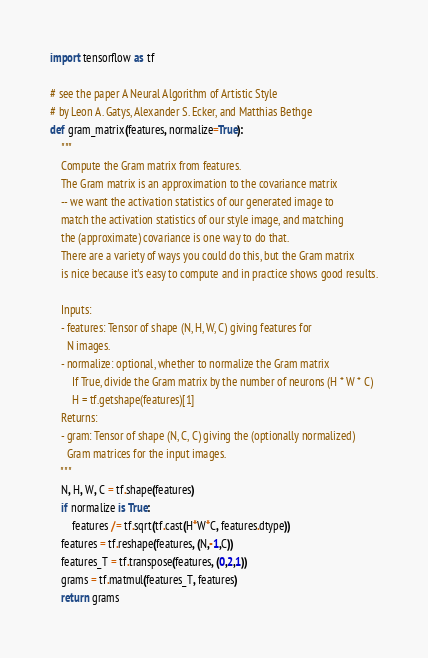Convert code to text. <code><loc_0><loc_0><loc_500><loc_500><_Python_>import tensorflow as tf

# see the paper A Neural Algorithm of Artistic Style 
# by Leon A. Gatys, Alexander S. Ecker, and Matthias Bethge
def gram_matrix(features, normalize=True):
    """
    Compute the Gram matrix from features.
    The Gram matrix is an approximation to the covariance matrix
    -- we want the activation statistics of our generated image to
    match the activation statistics of our style image, and matching
    the (approximate) covariance is one way to do that. 
    There are a variety of ways you could do this, but the Gram matrix
    is nice because it's easy to compute and in practice shows good results.

    Inputs:
    - features: Tensor of shape (N, H, W, C) giving features for
      N images.
    - normalize: optional, whether to normalize the Gram matrix
        If True, divide the Gram matrix by the number of neurons (H * W * C)
        H = tf.getshape(features)[1]
    Returns:
    - gram: Tensor of shape (N, C, C) giving the (optionally normalized)
      Gram matrices for the input images.
    """
    N, H, W, C = tf.shape(features)
    if normalize is True:
        features /= tf.sqrt(tf.cast(H*W*C, features.dtype))
    features = tf.reshape(features, (N,-1,C))
    features_T = tf.transpose(features, (0,2,1))
    grams = tf.matmul(features_T, features)
    return grams</code> 